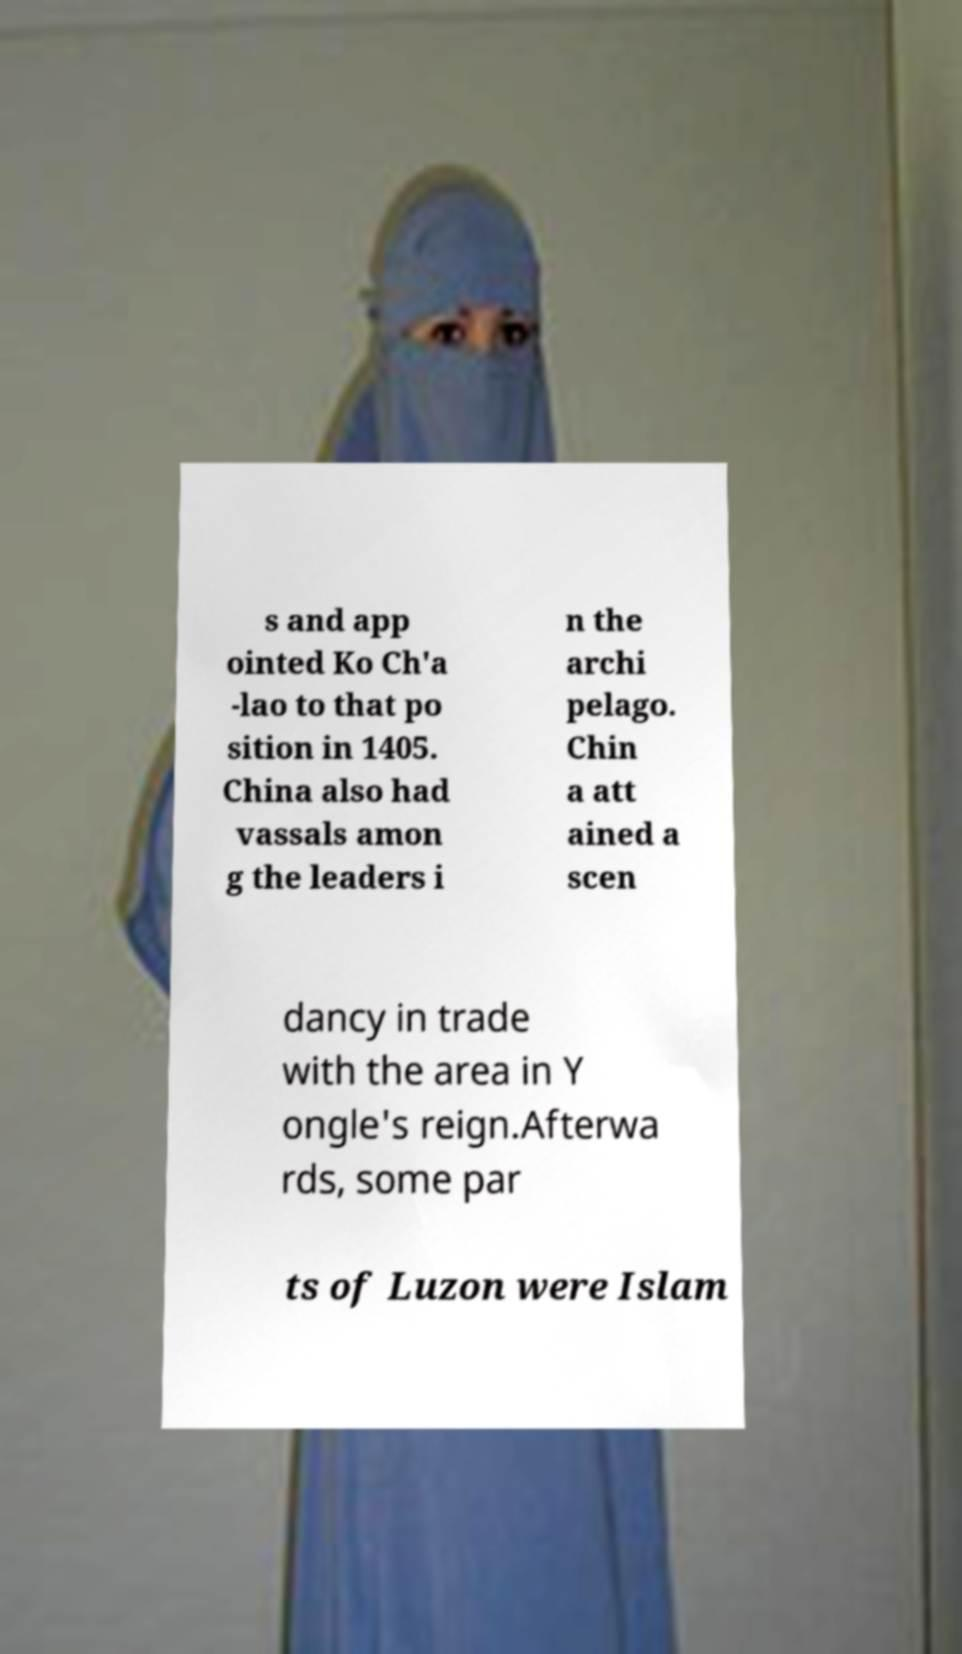Could you assist in decoding the text presented in this image and type it out clearly? s and app ointed Ko Ch'a -lao to that po sition in 1405. China also had vassals amon g the leaders i n the archi pelago. Chin a att ained a scen dancy in trade with the area in Y ongle's reign.Afterwa rds, some par ts of Luzon were Islam 